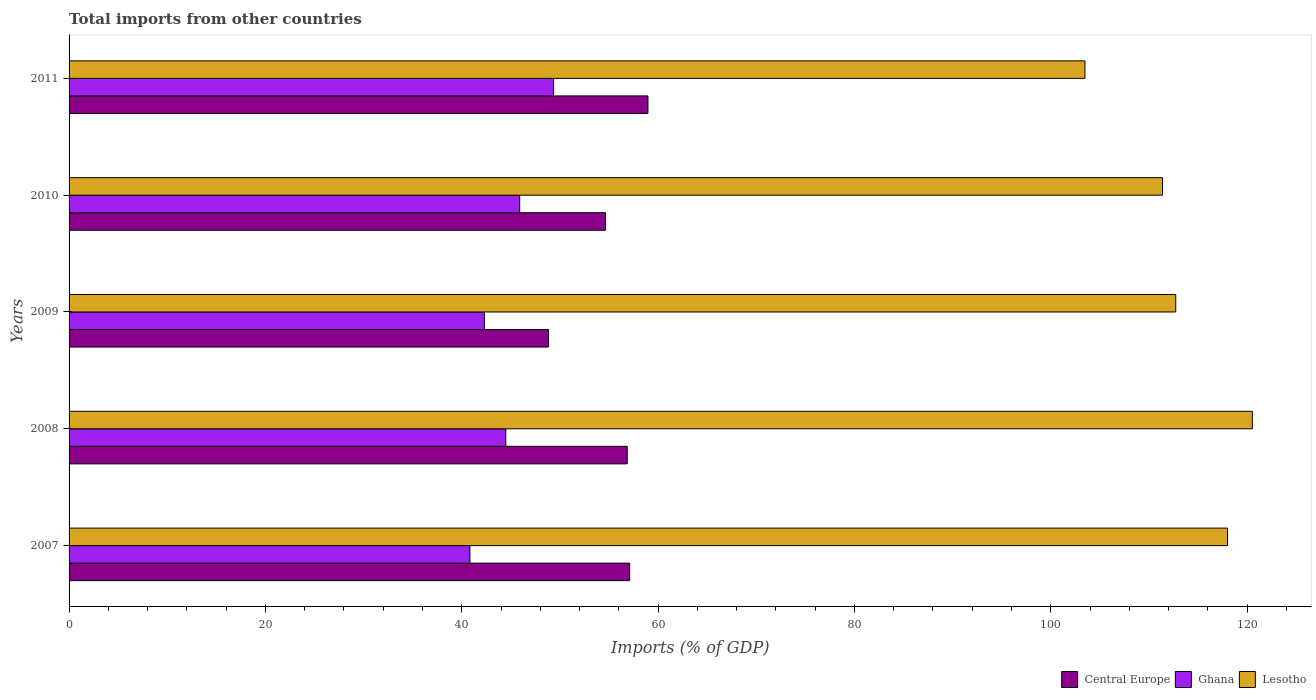How many different coloured bars are there?
Provide a short and direct response. 3. How many groups of bars are there?
Offer a terse response. 5. What is the label of the 4th group of bars from the top?
Your answer should be very brief. 2008. What is the total imports in Central Europe in 2010?
Provide a succinct answer. 54.64. Across all years, what is the maximum total imports in Central Europe?
Provide a short and direct response. 58.97. Across all years, what is the minimum total imports in Lesotho?
Ensure brevity in your answer.  103.48. What is the total total imports in Lesotho in the graph?
Offer a terse response. 566.12. What is the difference between the total imports in Central Europe in 2007 and that in 2010?
Provide a succinct answer. 2.46. What is the difference between the total imports in Ghana in 2009 and the total imports in Central Europe in 2007?
Provide a short and direct response. -14.8. What is the average total imports in Central Europe per year?
Make the answer very short. 55.28. In the year 2011, what is the difference between the total imports in Lesotho and total imports in Central Europe?
Offer a very short reply. 44.51. In how many years, is the total imports in Ghana greater than 96 %?
Provide a succinct answer. 0. What is the ratio of the total imports in Central Europe in 2007 to that in 2009?
Your answer should be compact. 1.17. What is the difference between the highest and the second highest total imports in Central Europe?
Provide a short and direct response. 1.86. What is the difference between the highest and the lowest total imports in Ghana?
Offer a terse response. 8.53. Is the sum of the total imports in Ghana in 2007 and 2008 greater than the maximum total imports in Central Europe across all years?
Make the answer very short. Yes. What does the 3rd bar from the top in 2010 represents?
Offer a terse response. Central Europe. What does the 3rd bar from the bottom in 2010 represents?
Your response must be concise. Lesotho. Is it the case that in every year, the sum of the total imports in Lesotho and total imports in Ghana is greater than the total imports in Central Europe?
Provide a succinct answer. Yes. How many bars are there?
Provide a short and direct response. 15. How many years are there in the graph?
Your answer should be very brief. 5. Does the graph contain grids?
Provide a short and direct response. No. How many legend labels are there?
Keep it short and to the point. 3. How are the legend labels stacked?
Make the answer very short. Horizontal. What is the title of the graph?
Keep it short and to the point. Total imports from other countries. What is the label or title of the X-axis?
Offer a very short reply. Imports (% of GDP). What is the Imports (% of GDP) in Central Europe in 2007?
Keep it short and to the point. 57.1. What is the Imports (% of GDP) of Ghana in 2007?
Your answer should be very brief. 40.83. What is the Imports (% of GDP) in Lesotho in 2007?
Offer a terse response. 118. What is the Imports (% of GDP) in Central Europe in 2008?
Provide a succinct answer. 56.85. What is the Imports (% of GDP) of Ghana in 2008?
Your answer should be very brief. 44.48. What is the Imports (% of GDP) of Lesotho in 2008?
Provide a succinct answer. 120.53. What is the Imports (% of GDP) in Central Europe in 2009?
Your answer should be very brief. 48.84. What is the Imports (% of GDP) of Ghana in 2009?
Make the answer very short. 42.3. What is the Imports (% of GDP) of Lesotho in 2009?
Make the answer very short. 112.73. What is the Imports (% of GDP) of Central Europe in 2010?
Make the answer very short. 54.64. What is the Imports (% of GDP) in Ghana in 2010?
Your answer should be very brief. 45.9. What is the Imports (% of GDP) of Lesotho in 2010?
Offer a very short reply. 111.38. What is the Imports (% of GDP) of Central Europe in 2011?
Ensure brevity in your answer.  58.97. What is the Imports (% of GDP) in Ghana in 2011?
Give a very brief answer. 49.36. What is the Imports (% of GDP) of Lesotho in 2011?
Offer a very short reply. 103.48. Across all years, what is the maximum Imports (% of GDP) of Central Europe?
Keep it short and to the point. 58.97. Across all years, what is the maximum Imports (% of GDP) of Ghana?
Your answer should be compact. 49.36. Across all years, what is the maximum Imports (% of GDP) of Lesotho?
Give a very brief answer. 120.53. Across all years, what is the minimum Imports (% of GDP) of Central Europe?
Ensure brevity in your answer.  48.84. Across all years, what is the minimum Imports (% of GDP) of Ghana?
Keep it short and to the point. 40.83. Across all years, what is the minimum Imports (% of GDP) in Lesotho?
Your response must be concise. 103.48. What is the total Imports (% of GDP) in Central Europe in the graph?
Keep it short and to the point. 276.41. What is the total Imports (% of GDP) in Ghana in the graph?
Offer a terse response. 222.88. What is the total Imports (% of GDP) of Lesotho in the graph?
Your response must be concise. 566.12. What is the difference between the Imports (% of GDP) in Central Europe in 2007 and that in 2008?
Offer a terse response. 0.25. What is the difference between the Imports (% of GDP) of Ghana in 2007 and that in 2008?
Provide a succinct answer. -3.66. What is the difference between the Imports (% of GDP) in Lesotho in 2007 and that in 2008?
Keep it short and to the point. -2.53. What is the difference between the Imports (% of GDP) of Central Europe in 2007 and that in 2009?
Your answer should be compact. 8.26. What is the difference between the Imports (% of GDP) in Ghana in 2007 and that in 2009?
Provide a succinct answer. -1.47. What is the difference between the Imports (% of GDP) of Lesotho in 2007 and that in 2009?
Provide a succinct answer. 5.27. What is the difference between the Imports (% of GDP) in Central Europe in 2007 and that in 2010?
Give a very brief answer. 2.46. What is the difference between the Imports (% of GDP) in Ghana in 2007 and that in 2010?
Ensure brevity in your answer.  -5.07. What is the difference between the Imports (% of GDP) of Lesotho in 2007 and that in 2010?
Give a very brief answer. 6.62. What is the difference between the Imports (% of GDP) of Central Europe in 2007 and that in 2011?
Your answer should be compact. -1.86. What is the difference between the Imports (% of GDP) in Ghana in 2007 and that in 2011?
Make the answer very short. -8.53. What is the difference between the Imports (% of GDP) in Lesotho in 2007 and that in 2011?
Keep it short and to the point. 14.52. What is the difference between the Imports (% of GDP) in Central Europe in 2008 and that in 2009?
Give a very brief answer. 8.01. What is the difference between the Imports (% of GDP) of Ghana in 2008 and that in 2009?
Offer a terse response. 2.18. What is the difference between the Imports (% of GDP) of Lesotho in 2008 and that in 2009?
Provide a succinct answer. 7.8. What is the difference between the Imports (% of GDP) in Central Europe in 2008 and that in 2010?
Give a very brief answer. 2.21. What is the difference between the Imports (% of GDP) of Ghana in 2008 and that in 2010?
Offer a very short reply. -1.42. What is the difference between the Imports (% of GDP) in Lesotho in 2008 and that in 2010?
Offer a very short reply. 9.15. What is the difference between the Imports (% of GDP) in Central Europe in 2008 and that in 2011?
Keep it short and to the point. -2.11. What is the difference between the Imports (% of GDP) of Ghana in 2008 and that in 2011?
Provide a succinct answer. -4.87. What is the difference between the Imports (% of GDP) in Lesotho in 2008 and that in 2011?
Offer a very short reply. 17.05. What is the difference between the Imports (% of GDP) of Central Europe in 2009 and that in 2010?
Give a very brief answer. -5.8. What is the difference between the Imports (% of GDP) of Ghana in 2009 and that in 2010?
Your answer should be compact. -3.6. What is the difference between the Imports (% of GDP) in Lesotho in 2009 and that in 2010?
Offer a very short reply. 1.34. What is the difference between the Imports (% of GDP) in Central Europe in 2009 and that in 2011?
Offer a terse response. -10.13. What is the difference between the Imports (% of GDP) of Ghana in 2009 and that in 2011?
Make the answer very short. -7.06. What is the difference between the Imports (% of GDP) of Lesotho in 2009 and that in 2011?
Provide a short and direct response. 9.25. What is the difference between the Imports (% of GDP) in Central Europe in 2010 and that in 2011?
Your answer should be very brief. -4.32. What is the difference between the Imports (% of GDP) in Ghana in 2010 and that in 2011?
Offer a very short reply. -3.46. What is the difference between the Imports (% of GDP) in Lesotho in 2010 and that in 2011?
Your answer should be very brief. 7.9. What is the difference between the Imports (% of GDP) of Central Europe in 2007 and the Imports (% of GDP) of Ghana in 2008?
Keep it short and to the point. 12.62. What is the difference between the Imports (% of GDP) in Central Europe in 2007 and the Imports (% of GDP) in Lesotho in 2008?
Make the answer very short. -63.43. What is the difference between the Imports (% of GDP) in Ghana in 2007 and the Imports (% of GDP) in Lesotho in 2008?
Make the answer very short. -79.7. What is the difference between the Imports (% of GDP) of Central Europe in 2007 and the Imports (% of GDP) of Ghana in 2009?
Offer a terse response. 14.8. What is the difference between the Imports (% of GDP) in Central Europe in 2007 and the Imports (% of GDP) in Lesotho in 2009?
Make the answer very short. -55.63. What is the difference between the Imports (% of GDP) in Ghana in 2007 and the Imports (% of GDP) in Lesotho in 2009?
Your answer should be very brief. -71.9. What is the difference between the Imports (% of GDP) in Central Europe in 2007 and the Imports (% of GDP) in Ghana in 2010?
Make the answer very short. 11.2. What is the difference between the Imports (% of GDP) in Central Europe in 2007 and the Imports (% of GDP) in Lesotho in 2010?
Make the answer very short. -54.28. What is the difference between the Imports (% of GDP) in Ghana in 2007 and the Imports (% of GDP) in Lesotho in 2010?
Provide a succinct answer. -70.55. What is the difference between the Imports (% of GDP) of Central Europe in 2007 and the Imports (% of GDP) of Ghana in 2011?
Your answer should be compact. 7.74. What is the difference between the Imports (% of GDP) in Central Europe in 2007 and the Imports (% of GDP) in Lesotho in 2011?
Your response must be concise. -46.38. What is the difference between the Imports (% of GDP) in Ghana in 2007 and the Imports (% of GDP) in Lesotho in 2011?
Keep it short and to the point. -62.65. What is the difference between the Imports (% of GDP) of Central Europe in 2008 and the Imports (% of GDP) of Ghana in 2009?
Make the answer very short. 14.55. What is the difference between the Imports (% of GDP) of Central Europe in 2008 and the Imports (% of GDP) of Lesotho in 2009?
Your answer should be very brief. -55.87. What is the difference between the Imports (% of GDP) in Ghana in 2008 and the Imports (% of GDP) in Lesotho in 2009?
Your response must be concise. -68.24. What is the difference between the Imports (% of GDP) of Central Europe in 2008 and the Imports (% of GDP) of Ghana in 2010?
Give a very brief answer. 10.95. What is the difference between the Imports (% of GDP) of Central Europe in 2008 and the Imports (% of GDP) of Lesotho in 2010?
Keep it short and to the point. -54.53. What is the difference between the Imports (% of GDP) of Ghana in 2008 and the Imports (% of GDP) of Lesotho in 2010?
Provide a short and direct response. -66.9. What is the difference between the Imports (% of GDP) of Central Europe in 2008 and the Imports (% of GDP) of Ghana in 2011?
Your answer should be compact. 7.5. What is the difference between the Imports (% of GDP) in Central Europe in 2008 and the Imports (% of GDP) in Lesotho in 2011?
Offer a very short reply. -46.63. What is the difference between the Imports (% of GDP) in Ghana in 2008 and the Imports (% of GDP) in Lesotho in 2011?
Your response must be concise. -59. What is the difference between the Imports (% of GDP) of Central Europe in 2009 and the Imports (% of GDP) of Ghana in 2010?
Give a very brief answer. 2.94. What is the difference between the Imports (% of GDP) of Central Europe in 2009 and the Imports (% of GDP) of Lesotho in 2010?
Provide a succinct answer. -62.54. What is the difference between the Imports (% of GDP) of Ghana in 2009 and the Imports (% of GDP) of Lesotho in 2010?
Keep it short and to the point. -69.08. What is the difference between the Imports (% of GDP) of Central Europe in 2009 and the Imports (% of GDP) of Ghana in 2011?
Make the answer very short. -0.52. What is the difference between the Imports (% of GDP) of Central Europe in 2009 and the Imports (% of GDP) of Lesotho in 2011?
Provide a short and direct response. -54.64. What is the difference between the Imports (% of GDP) in Ghana in 2009 and the Imports (% of GDP) in Lesotho in 2011?
Ensure brevity in your answer.  -61.18. What is the difference between the Imports (% of GDP) of Central Europe in 2010 and the Imports (% of GDP) of Ghana in 2011?
Keep it short and to the point. 5.28. What is the difference between the Imports (% of GDP) of Central Europe in 2010 and the Imports (% of GDP) of Lesotho in 2011?
Provide a short and direct response. -48.84. What is the difference between the Imports (% of GDP) of Ghana in 2010 and the Imports (% of GDP) of Lesotho in 2011?
Ensure brevity in your answer.  -57.58. What is the average Imports (% of GDP) in Central Europe per year?
Your answer should be very brief. 55.28. What is the average Imports (% of GDP) of Ghana per year?
Offer a terse response. 44.58. What is the average Imports (% of GDP) of Lesotho per year?
Give a very brief answer. 113.22. In the year 2007, what is the difference between the Imports (% of GDP) of Central Europe and Imports (% of GDP) of Ghana?
Ensure brevity in your answer.  16.27. In the year 2007, what is the difference between the Imports (% of GDP) of Central Europe and Imports (% of GDP) of Lesotho?
Offer a very short reply. -60.9. In the year 2007, what is the difference between the Imports (% of GDP) of Ghana and Imports (% of GDP) of Lesotho?
Give a very brief answer. -77.17. In the year 2008, what is the difference between the Imports (% of GDP) of Central Europe and Imports (% of GDP) of Ghana?
Give a very brief answer. 12.37. In the year 2008, what is the difference between the Imports (% of GDP) in Central Europe and Imports (% of GDP) in Lesotho?
Provide a short and direct response. -63.68. In the year 2008, what is the difference between the Imports (% of GDP) of Ghana and Imports (% of GDP) of Lesotho?
Make the answer very short. -76.05. In the year 2009, what is the difference between the Imports (% of GDP) in Central Europe and Imports (% of GDP) in Ghana?
Give a very brief answer. 6.54. In the year 2009, what is the difference between the Imports (% of GDP) in Central Europe and Imports (% of GDP) in Lesotho?
Make the answer very short. -63.89. In the year 2009, what is the difference between the Imports (% of GDP) of Ghana and Imports (% of GDP) of Lesotho?
Ensure brevity in your answer.  -70.42. In the year 2010, what is the difference between the Imports (% of GDP) of Central Europe and Imports (% of GDP) of Ghana?
Keep it short and to the point. 8.74. In the year 2010, what is the difference between the Imports (% of GDP) in Central Europe and Imports (% of GDP) in Lesotho?
Offer a very short reply. -56.74. In the year 2010, what is the difference between the Imports (% of GDP) in Ghana and Imports (% of GDP) in Lesotho?
Offer a very short reply. -65.48. In the year 2011, what is the difference between the Imports (% of GDP) in Central Europe and Imports (% of GDP) in Ghana?
Provide a short and direct response. 9.61. In the year 2011, what is the difference between the Imports (% of GDP) of Central Europe and Imports (% of GDP) of Lesotho?
Offer a terse response. -44.51. In the year 2011, what is the difference between the Imports (% of GDP) of Ghana and Imports (% of GDP) of Lesotho?
Give a very brief answer. -54.12. What is the ratio of the Imports (% of GDP) of Central Europe in 2007 to that in 2008?
Provide a short and direct response. 1. What is the ratio of the Imports (% of GDP) of Ghana in 2007 to that in 2008?
Your answer should be compact. 0.92. What is the ratio of the Imports (% of GDP) of Lesotho in 2007 to that in 2008?
Give a very brief answer. 0.98. What is the ratio of the Imports (% of GDP) of Central Europe in 2007 to that in 2009?
Make the answer very short. 1.17. What is the ratio of the Imports (% of GDP) in Ghana in 2007 to that in 2009?
Provide a short and direct response. 0.97. What is the ratio of the Imports (% of GDP) of Lesotho in 2007 to that in 2009?
Give a very brief answer. 1.05. What is the ratio of the Imports (% of GDP) of Central Europe in 2007 to that in 2010?
Your answer should be compact. 1.04. What is the ratio of the Imports (% of GDP) in Ghana in 2007 to that in 2010?
Your answer should be very brief. 0.89. What is the ratio of the Imports (% of GDP) of Lesotho in 2007 to that in 2010?
Give a very brief answer. 1.06. What is the ratio of the Imports (% of GDP) of Central Europe in 2007 to that in 2011?
Your response must be concise. 0.97. What is the ratio of the Imports (% of GDP) in Ghana in 2007 to that in 2011?
Your answer should be compact. 0.83. What is the ratio of the Imports (% of GDP) of Lesotho in 2007 to that in 2011?
Offer a terse response. 1.14. What is the ratio of the Imports (% of GDP) of Central Europe in 2008 to that in 2009?
Make the answer very short. 1.16. What is the ratio of the Imports (% of GDP) of Ghana in 2008 to that in 2009?
Offer a very short reply. 1.05. What is the ratio of the Imports (% of GDP) in Lesotho in 2008 to that in 2009?
Your response must be concise. 1.07. What is the ratio of the Imports (% of GDP) in Central Europe in 2008 to that in 2010?
Offer a very short reply. 1.04. What is the ratio of the Imports (% of GDP) of Ghana in 2008 to that in 2010?
Your answer should be very brief. 0.97. What is the ratio of the Imports (% of GDP) in Lesotho in 2008 to that in 2010?
Give a very brief answer. 1.08. What is the ratio of the Imports (% of GDP) in Central Europe in 2008 to that in 2011?
Ensure brevity in your answer.  0.96. What is the ratio of the Imports (% of GDP) of Ghana in 2008 to that in 2011?
Offer a very short reply. 0.9. What is the ratio of the Imports (% of GDP) in Lesotho in 2008 to that in 2011?
Provide a succinct answer. 1.16. What is the ratio of the Imports (% of GDP) of Central Europe in 2009 to that in 2010?
Provide a succinct answer. 0.89. What is the ratio of the Imports (% of GDP) in Ghana in 2009 to that in 2010?
Offer a very short reply. 0.92. What is the ratio of the Imports (% of GDP) of Lesotho in 2009 to that in 2010?
Make the answer very short. 1.01. What is the ratio of the Imports (% of GDP) in Central Europe in 2009 to that in 2011?
Your answer should be very brief. 0.83. What is the ratio of the Imports (% of GDP) in Ghana in 2009 to that in 2011?
Give a very brief answer. 0.86. What is the ratio of the Imports (% of GDP) of Lesotho in 2009 to that in 2011?
Provide a succinct answer. 1.09. What is the ratio of the Imports (% of GDP) in Central Europe in 2010 to that in 2011?
Keep it short and to the point. 0.93. What is the ratio of the Imports (% of GDP) of Ghana in 2010 to that in 2011?
Keep it short and to the point. 0.93. What is the ratio of the Imports (% of GDP) in Lesotho in 2010 to that in 2011?
Your answer should be compact. 1.08. What is the difference between the highest and the second highest Imports (% of GDP) in Central Europe?
Your answer should be very brief. 1.86. What is the difference between the highest and the second highest Imports (% of GDP) of Ghana?
Your answer should be compact. 3.46. What is the difference between the highest and the second highest Imports (% of GDP) of Lesotho?
Offer a terse response. 2.53. What is the difference between the highest and the lowest Imports (% of GDP) of Central Europe?
Keep it short and to the point. 10.13. What is the difference between the highest and the lowest Imports (% of GDP) in Ghana?
Make the answer very short. 8.53. What is the difference between the highest and the lowest Imports (% of GDP) in Lesotho?
Give a very brief answer. 17.05. 